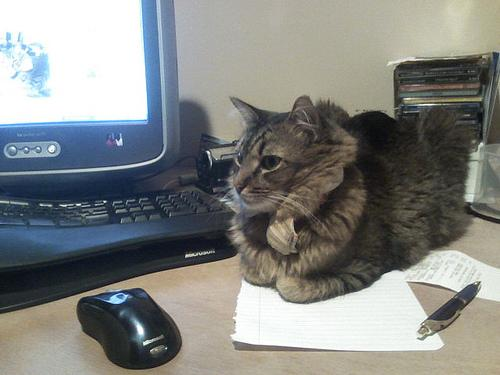Mention the primary focus of the image and its actions. A grey-striped cat is sitting on a piece of white paper on a desk with computer equipment, pens, and other stationery items. Summarize the most significant character in the image and its accompanying items. A grey cat sits on white paper on a desk accompanied by a computer setup, pens, a receipt, and a stack of CDs. Write a brief description of the key animal in the picture and what it's sitting on. A gray cat with white whiskers is perched on a blank piece of paper, amidst other items on a desk. List the items seen on the desk around the main subject of the image. A cat, computer, monitor, keyboard, mouse, white paper, stack of CDs, receipt, blue pen, and silver pen are present on the desk. Provide an overview of the central character in the image and what it is doing. A striped gray cat lies on a white paper sheet, surrounded by various desk items such as a computer, keyboard, and pens. Give a brief account of the image's leading animal and the environment it's in. On a cluttered desk, a tabby cat is lounging on a white sheet, surrounded by computer equipment and stationery items. Describe the foremost animal in the image and its surroundings. A tabby cat with fluffy grey fur is resting on a sheet of paper, surrounded by a computer, keyboard, mouse, receipts, and pens on a desk. Recount the leading figure in the image and describe the setting it is in. A furry grey cat lays on a sheet of paper amid an assortment of desk items, including a computer, keyboard, mouse, and pens. Illustrate the primary living being in the image and mention its whereabouts. A gray cat with tiger stripes is relaxing on a piece of white paper, situated among various items on a desk. Explain the main object in the picture, along with the notable items in its vicinity. A cat sits atop a white paper; around it, there's a computer, keyboard, mouse, screen, CDs, a receipt, and pens on the desk. 